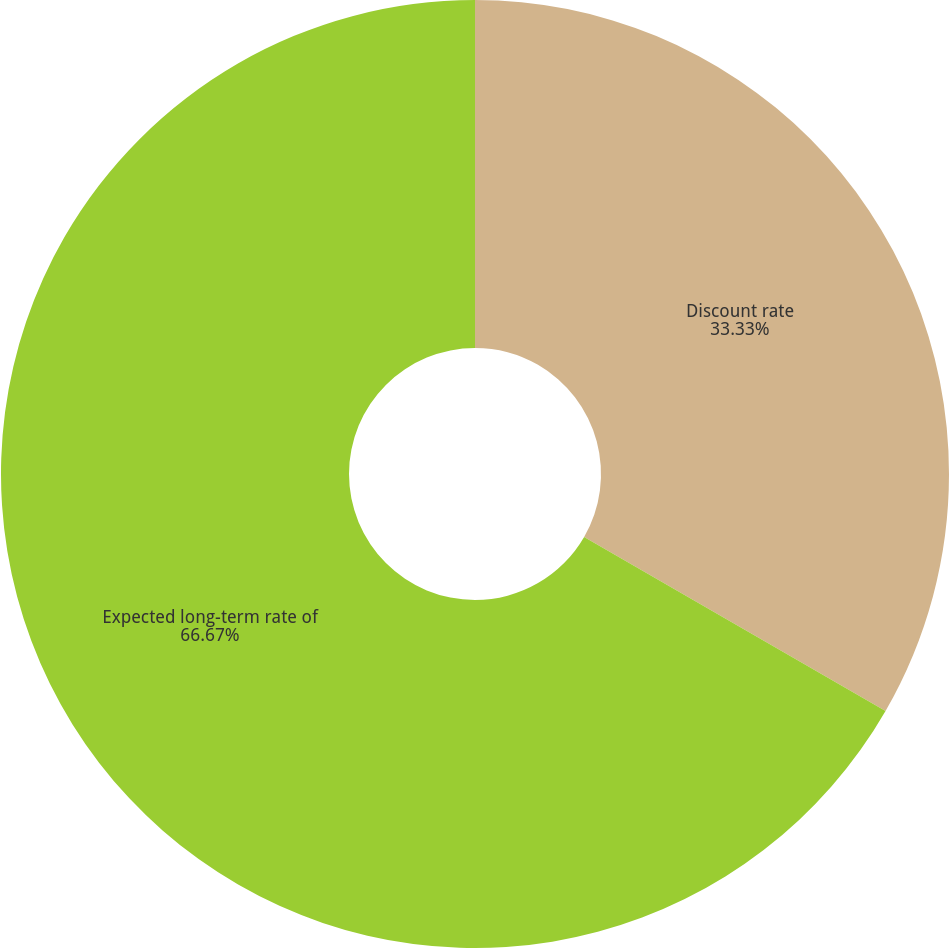Convert chart to OTSL. <chart><loc_0><loc_0><loc_500><loc_500><pie_chart><fcel>Discount rate<fcel>Expected long-term rate of<nl><fcel>33.33%<fcel>66.67%<nl></chart> 